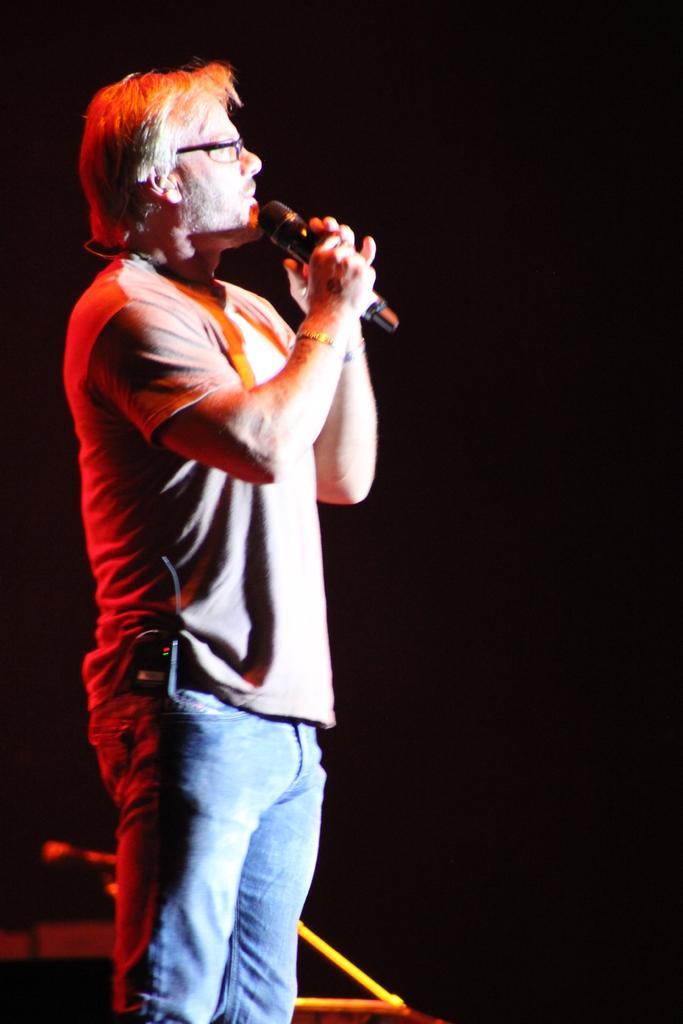Describe this image in one or two sentences. In this picture I can see there is a man standing and he is holding a microphone. The backdrop is dark. 